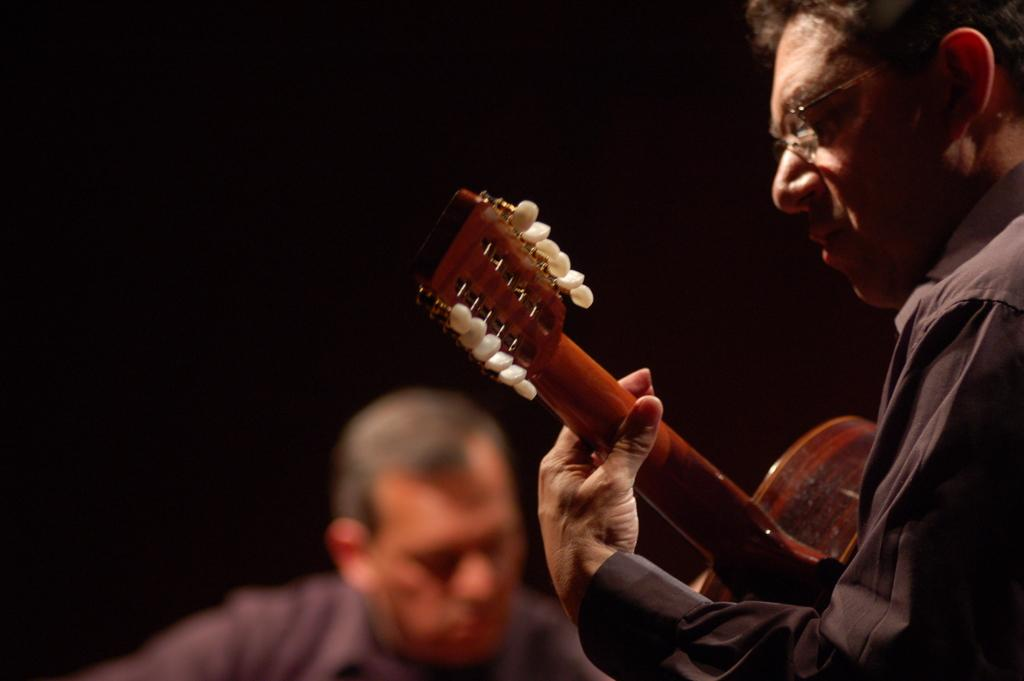How many people are in the image? There are two people in the image. What is one of the people doing in the image? One of the people is playing a guitar. Can you describe the appearance of the person playing the guitar? The person playing the guitar is wearing glasses. What type of fork can be seen being used to paint on the canvas in the image? There is no fork or canvas present in the image; it features two people, one of whom is playing a guitar. 